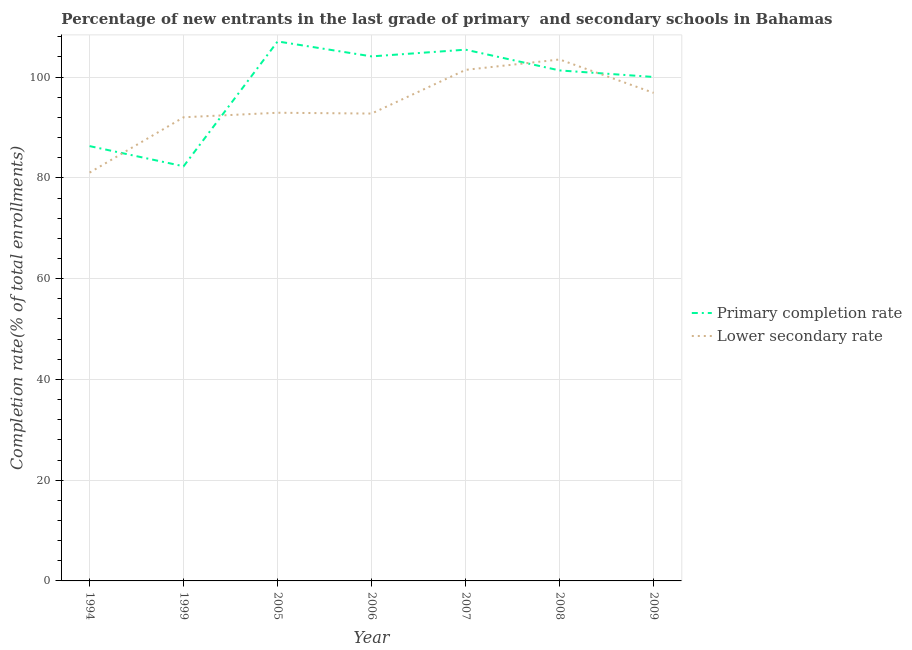Is the number of lines equal to the number of legend labels?
Keep it short and to the point. Yes. What is the completion rate in primary schools in 1999?
Keep it short and to the point. 82.3. Across all years, what is the maximum completion rate in primary schools?
Ensure brevity in your answer.  107.09. Across all years, what is the minimum completion rate in primary schools?
Offer a very short reply. 82.3. What is the total completion rate in primary schools in the graph?
Your response must be concise. 686.64. What is the difference between the completion rate in primary schools in 1999 and that in 2009?
Give a very brief answer. -17.73. What is the difference between the completion rate in primary schools in 2009 and the completion rate in secondary schools in 2006?
Offer a terse response. 7.26. What is the average completion rate in primary schools per year?
Provide a succinct answer. 98.09. In the year 2005, what is the difference between the completion rate in secondary schools and completion rate in primary schools?
Your answer should be compact. -14.16. In how many years, is the completion rate in primary schools greater than 100 %?
Ensure brevity in your answer.  5. What is the ratio of the completion rate in secondary schools in 2006 to that in 2008?
Keep it short and to the point. 0.9. Is the completion rate in secondary schools in 1994 less than that in 2006?
Your answer should be very brief. Yes. What is the difference between the highest and the second highest completion rate in primary schools?
Keep it short and to the point. 1.64. What is the difference between the highest and the lowest completion rate in primary schools?
Provide a short and direct response. 24.78. Is the sum of the completion rate in primary schools in 2006 and 2008 greater than the maximum completion rate in secondary schools across all years?
Give a very brief answer. Yes. Is the completion rate in primary schools strictly less than the completion rate in secondary schools over the years?
Offer a very short reply. No. How many lines are there?
Ensure brevity in your answer.  2. What is the difference between two consecutive major ticks on the Y-axis?
Your answer should be compact. 20. Does the graph contain grids?
Your answer should be compact. Yes. Where does the legend appear in the graph?
Provide a short and direct response. Center right. How many legend labels are there?
Keep it short and to the point. 2. What is the title of the graph?
Provide a short and direct response. Percentage of new entrants in the last grade of primary  and secondary schools in Bahamas. Does "Unregistered firms" appear as one of the legend labels in the graph?
Provide a short and direct response. No. What is the label or title of the Y-axis?
Make the answer very short. Completion rate(% of total enrollments). What is the Completion rate(% of total enrollments) in Primary completion rate in 1994?
Your answer should be very brief. 86.31. What is the Completion rate(% of total enrollments) of Lower secondary rate in 1994?
Offer a very short reply. 81.05. What is the Completion rate(% of total enrollments) in Primary completion rate in 1999?
Your response must be concise. 82.3. What is the Completion rate(% of total enrollments) in Lower secondary rate in 1999?
Your answer should be compact. 92.03. What is the Completion rate(% of total enrollments) in Primary completion rate in 2005?
Make the answer very short. 107.09. What is the Completion rate(% of total enrollments) in Lower secondary rate in 2005?
Offer a terse response. 92.93. What is the Completion rate(% of total enrollments) of Primary completion rate in 2006?
Keep it short and to the point. 104.12. What is the Completion rate(% of total enrollments) of Lower secondary rate in 2006?
Offer a very short reply. 92.77. What is the Completion rate(% of total enrollments) in Primary completion rate in 2007?
Provide a short and direct response. 105.45. What is the Completion rate(% of total enrollments) of Lower secondary rate in 2007?
Ensure brevity in your answer.  101.44. What is the Completion rate(% of total enrollments) in Primary completion rate in 2008?
Keep it short and to the point. 101.33. What is the Completion rate(% of total enrollments) in Lower secondary rate in 2008?
Offer a terse response. 103.5. What is the Completion rate(% of total enrollments) in Primary completion rate in 2009?
Ensure brevity in your answer.  100.03. What is the Completion rate(% of total enrollments) in Lower secondary rate in 2009?
Give a very brief answer. 96.88. Across all years, what is the maximum Completion rate(% of total enrollments) in Primary completion rate?
Your answer should be compact. 107.09. Across all years, what is the maximum Completion rate(% of total enrollments) in Lower secondary rate?
Your answer should be very brief. 103.5. Across all years, what is the minimum Completion rate(% of total enrollments) of Primary completion rate?
Your response must be concise. 82.3. Across all years, what is the minimum Completion rate(% of total enrollments) of Lower secondary rate?
Provide a short and direct response. 81.05. What is the total Completion rate(% of total enrollments) of Primary completion rate in the graph?
Your answer should be compact. 686.64. What is the total Completion rate(% of total enrollments) in Lower secondary rate in the graph?
Ensure brevity in your answer.  660.62. What is the difference between the Completion rate(% of total enrollments) in Primary completion rate in 1994 and that in 1999?
Make the answer very short. 4.01. What is the difference between the Completion rate(% of total enrollments) of Lower secondary rate in 1994 and that in 1999?
Give a very brief answer. -10.98. What is the difference between the Completion rate(% of total enrollments) in Primary completion rate in 1994 and that in 2005?
Your answer should be very brief. -20.78. What is the difference between the Completion rate(% of total enrollments) in Lower secondary rate in 1994 and that in 2005?
Give a very brief answer. -11.88. What is the difference between the Completion rate(% of total enrollments) in Primary completion rate in 1994 and that in 2006?
Offer a terse response. -17.81. What is the difference between the Completion rate(% of total enrollments) in Lower secondary rate in 1994 and that in 2006?
Provide a short and direct response. -11.72. What is the difference between the Completion rate(% of total enrollments) in Primary completion rate in 1994 and that in 2007?
Your response must be concise. -19.14. What is the difference between the Completion rate(% of total enrollments) of Lower secondary rate in 1994 and that in 2007?
Provide a succinct answer. -20.39. What is the difference between the Completion rate(% of total enrollments) of Primary completion rate in 1994 and that in 2008?
Keep it short and to the point. -15.02. What is the difference between the Completion rate(% of total enrollments) in Lower secondary rate in 1994 and that in 2008?
Offer a very short reply. -22.45. What is the difference between the Completion rate(% of total enrollments) in Primary completion rate in 1994 and that in 2009?
Your answer should be compact. -13.72. What is the difference between the Completion rate(% of total enrollments) in Lower secondary rate in 1994 and that in 2009?
Give a very brief answer. -15.83. What is the difference between the Completion rate(% of total enrollments) of Primary completion rate in 1999 and that in 2005?
Give a very brief answer. -24.78. What is the difference between the Completion rate(% of total enrollments) of Lower secondary rate in 1999 and that in 2005?
Provide a short and direct response. -0.9. What is the difference between the Completion rate(% of total enrollments) in Primary completion rate in 1999 and that in 2006?
Provide a succinct answer. -21.81. What is the difference between the Completion rate(% of total enrollments) of Lower secondary rate in 1999 and that in 2006?
Your response must be concise. -0.73. What is the difference between the Completion rate(% of total enrollments) of Primary completion rate in 1999 and that in 2007?
Offer a terse response. -23.15. What is the difference between the Completion rate(% of total enrollments) in Lower secondary rate in 1999 and that in 2007?
Give a very brief answer. -9.41. What is the difference between the Completion rate(% of total enrollments) of Primary completion rate in 1999 and that in 2008?
Make the answer very short. -19.03. What is the difference between the Completion rate(% of total enrollments) of Lower secondary rate in 1999 and that in 2008?
Keep it short and to the point. -11.47. What is the difference between the Completion rate(% of total enrollments) of Primary completion rate in 1999 and that in 2009?
Offer a very short reply. -17.73. What is the difference between the Completion rate(% of total enrollments) in Lower secondary rate in 1999 and that in 2009?
Offer a very short reply. -4.85. What is the difference between the Completion rate(% of total enrollments) of Primary completion rate in 2005 and that in 2006?
Offer a terse response. 2.97. What is the difference between the Completion rate(% of total enrollments) in Lower secondary rate in 2005 and that in 2006?
Offer a very short reply. 0.16. What is the difference between the Completion rate(% of total enrollments) in Primary completion rate in 2005 and that in 2007?
Keep it short and to the point. 1.64. What is the difference between the Completion rate(% of total enrollments) of Lower secondary rate in 2005 and that in 2007?
Give a very brief answer. -8.51. What is the difference between the Completion rate(% of total enrollments) in Primary completion rate in 2005 and that in 2008?
Make the answer very short. 5.76. What is the difference between the Completion rate(% of total enrollments) of Lower secondary rate in 2005 and that in 2008?
Make the answer very short. -10.57. What is the difference between the Completion rate(% of total enrollments) of Primary completion rate in 2005 and that in 2009?
Ensure brevity in your answer.  7.05. What is the difference between the Completion rate(% of total enrollments) of Lower secondary rate in 2005 and that in 2009?
Your response must be concise. -3.95. What is the difference between the Completion rate(% of total enrollments) of Primary completion rate in 2006 and that in 2007?
Your answer should be compact. -1.33. What is the difference between the Completion rate(% of total enrollments) in Lower secondary rate in 2006 and that in 2007?
Provide a short and direct response. -8.67. What is the difference between the Completion rate(% of total enrollments) of Primary completion rate in 2006 and that in 2008?
Offer a terse response. 2.79. What is the difference between the Completion rate(% of total enrollments) in Lower secondary rate in 2006 and that in 2008?
Make the answer very short. -10.73. What is the difference between the Completion rate(% of total enrollments) in Primary completion rate in 2006 and that in 2009?
Provide a succinct answer. 4.08. What is the difference between the Completion rate(% of total enrollments) of Lower secondary rate in 2006 and that in 2009?
Offer a terse response. -4.11. What is the difference between the Completion rate(% of total enrollments) in Primary completion rate in 2007 and that in 2008?
Offer a terse response. 4.12. What is the difference between the Completion rate(% of total enrollments) in Lower secondary rate in 2007 and that in 2008?
Provide a short and direct response. -2.06. What is the difference between the Completion rate(% of total enrollments) in Primary completion rate in 2007 and that in 2009?
Offer a terse response. 5.42. What is the difference between the Completion rate(% of total enrollments) of Lower secondary rate in 2007 and that in 2009?
Make the answer very short. 4.56. What is the difference between the Completion rate(% of total enrollments) of Primary completion rate in 2008 and that in 2009?
Your answer should be very brief. 1.3. What is the difference between the Completion rate(% of total enrollments) of Lower secondary rate in 2008 and that in 2009?
Offer a very short reply. 6.62. What is the difference between the Completion rate(% of total enrollments) of Primary completion rate in 1994 and the Completion rate(% of total enrollments) of Lower secondary rate in 1999?
Your answer should be very brief. -5.72. What is the difference between the Completion rate(% of total enrollments) of Primary completion rate in 1994 and the Completion rate(% of total enrollments) of Lower secondary rate in 2005?
Give a very brief answer. -6.62. What is the difference between the Completion rate(% of total enrollments) in Primary completion rate in 1994 and the Completion rate(% of total enrollments) in Lower secondary rate in 2006?
Your response must be concise. -6.46. What is the difference between the Completion rate(% of total enrollments) of Primary completion rate in 1994 and the Completion rate(% of total enrollments) of Lower secondary rate in 2007?
Make the answer very short. -15.13. What is the difference between the Completion rate(% of total enrollments) of Primary completion rate in 1994 and the Completion rate(% of total enrollments) of Lower secondary rate in 2008?
Make the answer very short. -17.19. What is the difference between the Completion rate(% of total enrollments) in Primary completion rate in 1994 and the Completion rate(% of total enrollments) in Lower secondary rate in 2009?
Offer a very short reply. -10.57. What is the difference between the Completion rate(% of total enrollments) in Primary completion rate in 1999 and the Completion rate(% of total enrollments) in Lower secondary rate in 2005?
Your answer should be compact. -10.63. What is the difference between the Completion rate(% of total enrollments) in Primary completion rate in 1999 and the Completion rate(% of total enrollments) in Lower secondary rate in 2006?
Your answer should be very brief. -10.47. What is the difference between the Completion rate(% of total enrollments) in Primary completion rate in 1999 and the Completion rate(% of total enrollments) in Lower secondary rate in 2007?
Ensure brevity in your answer.  -19.14. What is the difference between the Completion rate(% of total enrollments) in Primary completion rate in 1999 and the Completion rate(% of total enrollments) in Lower secondary rate in 2008?
Give a very brief answer. -21.2. What is the difference between the Completion rate(% of total enrollments) of Primary completion rate in 1999 and the Completion rate(% of total enrollments) of Lower secondary rate in 2009?
Your answer should be compact. -14.58. What is the difference between the Completion rate(% of total enrollments) in Primary completion rate in 2005 and the Completion rate(% of total enrollments) in Lower secondary rate in 2006?
Keep it short and to the point. 14.32. What is the difference between the Completion rate(% of total enrollments) of Primary completion rate in 2005 and the Completion rate(% of total enrollments) of Lower secondary rate in 2007?
Ensure brevity in your answer.  5.65. What is the difference between the Completion rate(% of total enrollments) of Primary completion rate in 2005 and the Completion rate(% of total enrollments) of Lower secondary rate in 2008?
Provide a short and direct response. 3.58. What is the difference between the Completion rate(% of total enrollments) of Primary completion rate in 2005 and the Completion rate(% of total enrollments) of Lower secondary rate in 2009?
Keep it short and to the point. 10.21. What is the difference between the Completion rate(% of total enrollments) in Primary completion rate in 2006 and the Completion rate(% of total enrollments) in Lower secondary rate in 2007?
Your response must be concise. 2.68. What is the difference between the Completion rate(% of total enrollments) of Primary completion rate in 2006 and the Completion rate(% of total enrollments) of Lower secondary rate in 2008?
Ensure brevity in your answer.  0.61. What is the difference between the Completion rate(% of total enrollments) of Primary completion rate in 2006 and the Completion rate(% of total enrollments) of Lower secondary rate in 2009?
Your response must be concise. 7.24. What is the difference between the Completion rate(% of total enrollments) of Primary completion rate in 2007 and the Completion rate(% of total enrollments) of Lower secondary rate in 2008?
Offer a terse response. 1.95. What is the difference between the Completion rate(% of total enrollments) in Primary completion rate in 2007 and the Completion rate(% of total enrollments) in Lower secondary rate in 2009?
Give a very brief answer. 8.57. What is the difference between the Completion rate(% of total enrollments) of Primary completion rate in 2008 and the Completion rate(% of total enrollments) of Lower secondary rate in 2009?
Give a very brief answer. 4.45. What is the average Completion rate(% of total enrollments) of Primary completion rate per year?
Provide a succinct answer. 98.09. What is the average Completion rate(% of total enrollments) of Lower secondary rate per year?
Your answer should be very brief. 94.37. In the year 1994, what is the difference between the Completion rate(% of total enrollments) in Primary completion rate and Completion rate(% of total enrollments) in Lower secondary rate?
Offer a terse response. 5.26. In the year 1999, what is the difference between the Completion rate(% of total enrollments) in Primary completion rate and Completion rate(% of total enrollments) in Lower secondary rate?
Ensure brevity in your answer.  -9.73. In the year 2005, what is the difference between the Completion rate(% of total enrollments) in Primary completion rate and Completion rate(% of total enrollments) in Lower secondary rate?
Your response must be concise. 14.16. In the year 2006, what is the difference between the Completion rate(% of total enrollments) of Primary completion rate and Completion rate(% of total enrollments) of Lower secondary rate?
Your answer should be very brief. 11.35. In the year 2007, what is the difference between the Completion rate(% of total enrollments) in Primary completion rate and Completion rate(% of total enrollments) in Lower secondary rate?
Offer a very short reply. 4.01. In the year 2008, what is the difference between the Completion rate(% of total enrollments) in Primary completion rate and Completion rate(% of total enrollments) in Lower secondary rate?
Your answer should be very brief. -2.17. In the year 2009, what is the difference between the Completion rate(% of total enrollments) of Primary completion rate and Completion rate(% of total enrollments) of Lower secondary rate?
Give a very brief answer. 3.15. What is the ratio of the Completion rate(% of total enrollments) in Primary completion rate in 1994 to that in 1999?
Make the answer very short. 1.05. What is the ratio of the Completion rate(% of total enrollments) of Lower secondary rate in 1994 to that in 1999?
Ensure brevity in your answer.  0.88. What is the ratio of the Completion rate(% of total enrollments) in Primary completion rate in 1994 to that in 2005?
Ensure brevity in your answer.  0.81. What is the ratio of the Completion rate(% of total enrollments) of Lower secondary rate in 1994 to that in 2005?
Ensure brevity in your answer.  0.87. What is the ratio of the Completion rate(% of total enrollments) of Primary completion rate in 1994 to that in 2006?
Your answer should be very brief. 0.83. What is the ratio of the Completion rate(% of total enrollments) of Lower secondary rate in 1994 to that in 2006?
Provide a short and direct response. 0.87. What is the ratio of the Completion rate(% of total enrollments) in Primary completion rate in 1994 to that in 2007?
Offer a very short reply. 0.82. What is the ratio of the Completion rate(% of total enrollments) of Lower secondary rate in 1994 to that in 2007?
Your response must be concise. 0.8. What is the ratio of the Completion rate(% of total enrollments) of Primary completion rate in 1994 to that in 2008?
Offer a very short reply. 0.85. What is the ratio of the Completion rate(% of total enrollments) of Lower secondary rate in 1994 to that in 2008?
Offer a very short reply. 0.78. What is the ratio of the Completion rate(% of total enrollments) of Primary completion rate in 1994 to that in 2009?
Ensure brevity in your answer.  0.86. What is the ratio of the Completion rate(% of total enrollments) in Lower secondary rate in 1994 to that in 2009?
Provide a succinct answer. 0.84. What is the ratio of the Completion rate(% of total enrollments) of Primary completion rate in 1999 to that in 2005?
Your answer should be very brief. 0.77. What is the ratio of the Completion rate(% of total enrollments) in Lower secondary rate in 1999 to that in 2005?
Offer a terse response. 0.99. What is the ratio of the Completion rate(% of total enrollments) of Primary completion rate in 1999 to that in 2006?
Your response must be concise. 0.79. What is the ratio of the Completion rate(% of total enrollments) in Lower secondary rate in 1999 to that in 2006?
Ensure brevity in your answer.  0.99. What is the ratio of the Completion rate(% of total enrollments) of Primary completion rate in 1999 to that in 2007?
Make the answer very short. 0.78. What is the ratio of the Completion rate(% of total enrollments) in Lower secondary rate in 1999 to that in 2007?
Your answer should be compact. 0.91. What is the ratio of the Completion rate(% of total enrollments) in Primary completion rate in 1999 to that in 2008?
Give a very brief answer. 0.81. What is the ratio of the Completion rate(% of total enrollments) in Lower secondary rate in 1999 to that in 2008?
Ensure brevity in your answer.  0.89. What is the ratio of the Completion rate(% of total enrollments) of Primary completion rate in 1999 to that in 2009?
Your answer should be compact. 0.82. What is the ratio of the Completion rate(% of total enrollments) in Lower secondary rate in 1999 to that in 2009?
Your answer should be very brief. 0.95. What is the ratio of the Completion rate(% of total enrollments) in Primary completion rate in 2005 to that in 2006?
Give a very brief answer. 1.03. What is the ratio of the Completion rate(% of total enrollments) of Primary completion rate in 2005 to that in 2007?
Give a very brief answer. 1.02. What is the ratio of the Completion rate(% of total enrollments) of Lower secondary rate in 2005 to that in 2007?
Provide a succinct answer. 0.92. What is the ratio of the Completion rate(% of total enrollments) in Primary completion rate in 2005 to that in 2008?
Give a very brief answer. 1.06. What is the ratio of the Completion rate(% of total enrollments) of Lower secondary rate in 2005 to that in 2008?
Offer a very short reply. 0.9. What is the ratio of the Completion rate(% of total enrollments) in Primary completion rate in 2005 to that in 2009?
Ensure brevity in your answer.  1.07. What is the ratio of the Completion rate(% of total enrollments) of Lower secondary rate in 2005 to that in 2009?
Give a very brief answer. 0.96. What is the ratio of the Completion rate(% of total enrollments) in Primary completion rate in 2006 to that in 2007?
Provide a short and direct response. 0.99. What is the ratio of the Completion rate(% of total enrollments) in Lower secondary rate in 2006 to that in 2007?
Give a very brief answer. 0.91. What is the ratio of the Completion rate(% of total enrollments) of Primary completion rate in 2006 to that in 2008?
Provide a succinct answer. 1.03. What is the ratio of the Completion rate(% of total enrollments) in Lower secondary rate in 2006 to that in 2008?
Your answer should be compact. 0.9. What is the ratio of the Completion rate(% of total enrollments) of Primary completion rate in 2006 to that in 2009?
Provide a succinct answer. 1.04. What is the ratio of the Completion rate(% of total enrollments) in Lower secondary rate in 2006 to that in 2009?
Make the answer very short. 0.96. What is the ratio of the Completion rate(% of total enrollments) of Primary completion rate in 2007 to that in 2008?
Your answer should be compact. 1.04. What is the ratio of the Completion rate(% of total enrollments) in Lower secondary rate in 2007 to that in 2008?
Offer a terse response. 0.98. What is the ratio of the Completion rate(% of total enrollments) of Primary completion rate in 2007 to that in 2009?
Provide a short and direct response. 1.05. What is the ratio of the Completion rate(% of total enrollments) of Lower secondary rate in 2007 to that in 2009?
Your answer should be compact. 1.05. What is the ratio of the Completion rate(% of total enrollments) in Lower secondary rate in 2008 to that in 2009?
Ensure brevity in your answer.  1.07. What is the difference between the highest and the second highest Completion rate(% of total enrollments) in Primary completion rate?
Ensure brevity in your answer.  1.64. What is the difference between the highest and the second highest Completion rate(% of total enrollments) of Lower secondary rate?
Your answer should be compact. 2.06. What is the difference between the highest and the lowest Completion rate(% of total enrollments) of Primary completion rate?
Provide a short and direct response. 24.78. What is the difference between the highest and the lowest Completion rate(% of total enrollments) in Lower secondary rate?
Keep it short and to the point. 22.45. 